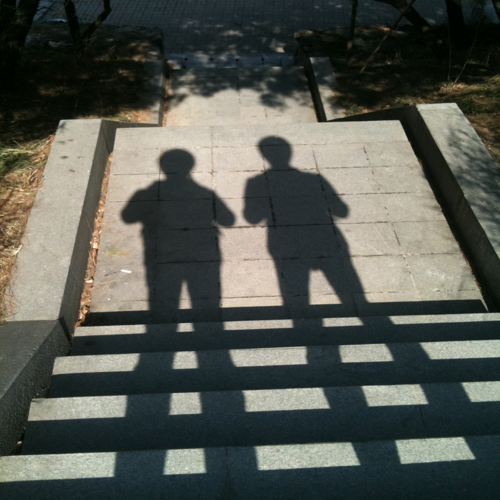Can you describe the atmosphere or mood conveyed by this image? The image evokes a serene and contemplative mood. The interplay of light and shadow creates a sense of calm and stillness, suggesting a quiet moment in a possibly bustling day. 